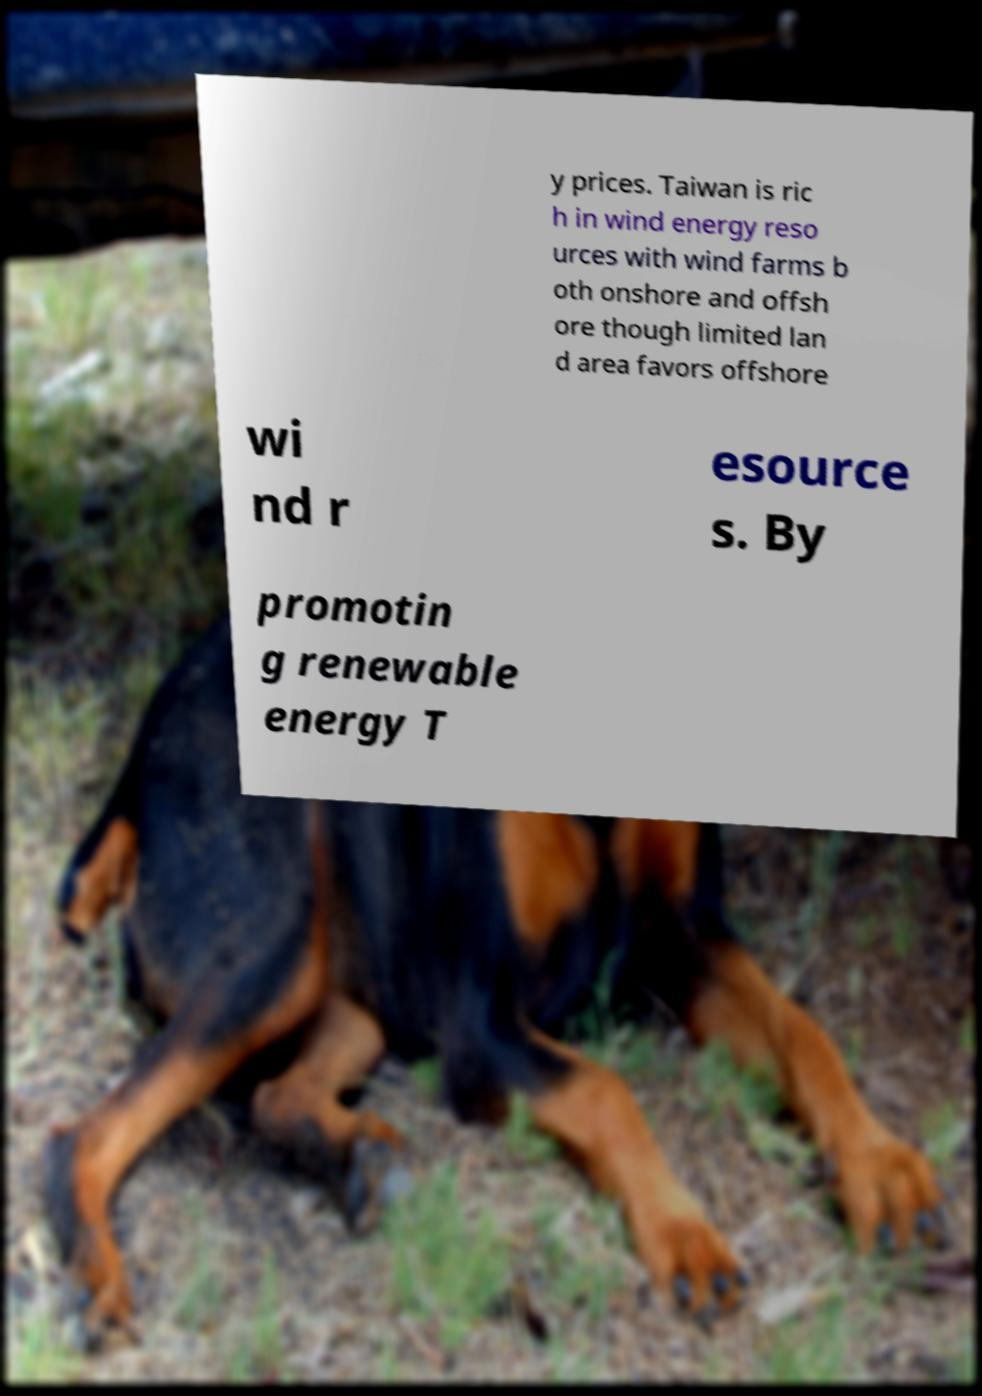Could you extract and type out the text from this image? y prices. Taiwan is ric h in wind energy reso urces with wind farms b oth onshore and offsh ore though limited lan d area favors offshore wi nd r esource s. By promotin g renewable energy T 